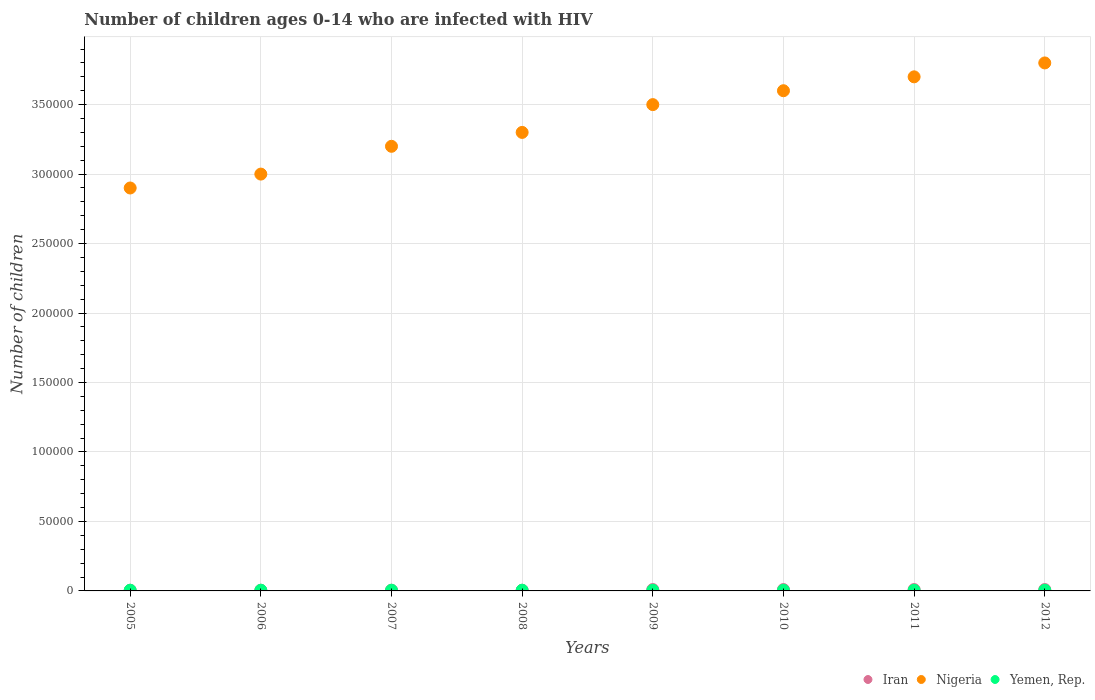Is the number of dotlines equal to the number of legend labels?
Make the answer very short. Yes. What is the number of HIV infected children in Yemen, Rep. in 2008?
Offer a terse response. 500. Across all years, what is the maximum number of HIV infected children in Yemen, Rep.?
Your answer should be compact. 500. Across all years, what is the minimum number of HIV infected children in Iran?
Provide a succinct answer. 500. In which year was the number of HIV infected children in Iran maximum?
Offer a terse response. 2009. What is the total number of HIV infected children in Yemen, Rep. in the graph?
Make the answer very short. 4000. What is the difference between the number of HIV infected children in Iran in 2005 and that in 2008?
Ensure brevity in your answer.  0. What is the difference between the number of HIV infected children in Iran in 2012 and the number of HIV infected children in Nigeria in 2008?
Provide a short and direct response. -3.29e+05. What is the average number of HIV infected children in Yemen, Rep. per year?
Ensure brevity in your answer.  500. In the year 2006, what is the difference between the number of HIV infected children in Yemen, Rep. and number of HIV infected children in Nigeria?
Offer a terse response. -3.00e+05. What is the ratio of the number of HIV infected children in Nigeria in 2005 to that in 2007?
Offer a terse response. 0.91. Is the number of HIV infected children in Yemen, Rep. in 2005 less than that in 2010?
Offer a terse response. No. What is the difference between the highest and the second highest number of HIV infected children in Iran?
Give a very brief answer. 0. What is the difference between the highest and the lowest number of HIV infected children in Yemen, Rep.?
Provide a short and direct response. 0. In how many years, is the number of HIV infected children in Nigeria greater than the average number of HIV infected children in Nigeria taken over all years?
Make the answer very short. 4. How many dotlines are there?
Ensure brevity in your answer.  3. Does the graph contain any zero values?
Ensure brevity in your answer.  No. Where does the legend appear in the graph?
Ensure brevity in your answer.  Bottom right. How many legend labels are there?
Make the answer very short. 3. What is the title of the graph?
Make the answer very short. Number of children ages 0-14 who are infected with HIV. What is the label or title of the X-axis?
Your response must be concise. Years. What is the label or title of the Y-axis?
Provide a succinct answer. Number of children. What is the Number of children of Iran in 2005?
Ensure brevity in your answer.  500. What is the Number of children of Nigeria in 2005?
Make the answer very short. 2.90e+05. What is the Number of children in Yemen, Rep. in 2005?
Offer a terse response. 500. What is the Number of children of Nigeria in 2006?
Your response must be concise. 3.00e+05. What is the Number of children of Nigeria in 2007?
Ensure brevity in your answer.  3.20e+05. What is the Number of children in Nigeria in 2008?
Ensure brevity in your answer.  3.30e+05. What is the Number of children in Yemen, Rep. in 2008?
Your answer should be very brief. 500. What is the Number of children of Nigeria in 2009?
Offer a very short reply. 3.50e+05. What is the Number of children in Yemen, Rep. in 2009?
Provide a succinct answer. 500. What is the Number of children of Yemen, Rep. in 2010?
Offer a very short reply. 500. What is the Number of children in Iran in 2011?
Provide a short and direct response. 1000. What is the Number of children in Yemen, Rep. in 2011?
Offer a very short reply. 500. What is the Number of children in Iran in 2012?
Offer a terse response. 1000. What is the Number of children in Yemen, Rep. in 2012?
Provide a succinct answer. 500. Across all years, what is the maximum Number of children of Iran?
Provide a succinct answer. 1000. Across all years, what is the maximum Number of children of Yemen, Rep.?
Your response must be concise. 500. What is the total Number of children in Iran in the graph?
Give a very brief answer. 6000. What is the total Number of children of Nigeria in the graph?
Ensure brevity in your answer.  2.70e+06. What is the total Number of children in Yemen, Rep. in the graph?
Your answer should be very brief. 4000. What is the difference between the Number of children in Yemen, Rep. in 2005 and that in 2006?
Offer a very short reply. 0. What is the difference between the Number of children in Iran in 2005 and that in 2007?
Provide a succinct answer. 0. What is the difference between the Number of children of Nigeria in 2005 and that in 2008?
Your answer should be compact. -4.00e+04. What is the difference between the Number of children of Yemen, Rep. in 2005 and that in 2008?
Your answer should be very brief. 0. What is the difference between the Number of children in Iran in 2005 and that in 2009?
Keep it short and to the point. -500. What is the difference between the Number of children in Nigeria in 2005 and that in 2009?
Give a very brief answer. -6.00e+04. What is the difference between the Number of children of Iran in 2005 and that in 2010?
Offer a very short reply. -500. What is the difference between the Number of children of Nigeria in 2005 and that in 2010?
Ensure brevity in your answer.  -7.00e+04. What is the difference between the Number of children of Yemen, Rep. in 2005 and that in 2010?
Make the answer very short. 0. What is the difference between the Number of children of Iran in 2005 and that in 2011?
Your answer should be very brief. -500. What is the difference between the Number of children of Iran in 2005 and that in 2012?
Give a very brief answer. -500. What is the difference between the Number of children in Yemen, Rep. in 2006 and that in 2007?
Ensure brevity in your answer.  0. What is the difference between the Number of children of Iran in 2006 and that in 2008?
Your response must be concise. 0. What is the difference between the Number of children in Yemen, Rep. in 2006 and that in 2008?
Your answer should be compact. 0. What is the difference between the Number of children of Iran in 2006 and that in 2009?
Offer a very short reply. -500. What is the difference between the Number of children in Nigeria in 2006 and that in 2009?
Give a very brief answer. -5.00e+04. What is the difference between the Number of children of Iran in 2006 and that in 2010?
Provide a short and direct response. -500. What is the difference between the Number of children of Iran in 2006 and that in 2011?
Keep it short and to the point. -500. What is the difference between the Number of children of Nigeria in 2006 and that in 2011?
Ensure brevity in your answer.  -7.00e+04. What is the difference between the Number of children in Iran in 2006 and that in 2012?
Make the answer very short. -500. What is the difference between the Number of children of Nigeria in 2007 and that in 2008?
Ensure brevity in your answer.  -10000. What is the difference between the Number of children of Yemen, Rep. in 2007 and that in 2008?
Provide a succinct answer. 0. What is the difference between the Number of children in Iran in 2007 and that in 2009?
Provide a succinct answer. -500. What is the difference between the Number of children of Nigeria in 2007 and that in 2009?
Provide a short and direct response. -3.00e+04. What is the difference between the Number of children in Yemen, Rep. in 2007 and that in 2009?
Provide a succinct answer. 0. What is the difference between the Number of children in Iran in 2007 and that in 2010?
Your answer should be very brief. -500. What is the difference between the Number of children in Yemen, Rep. in 2007 and that in 2010?
Ensure brevity in your answer.  0. What is the difference between the Number of children of Iran in 2007 and that in 2011?
Provide a succinct answer. -500. What is the difference between the Number of children of Nigeria in 2007 and that in 2011?
Offer a very short reply. -5.00e+04. What is the difference between the Number of children of Iran in 2007 and that in 2012?
Your answer should be very brief. -500. What is the difference between the Number of children of Yemen, Rep. in 2007 and that in 2012?
Offer a very short reply. 0. What is the difference between the Number of children in Iran in 2008 and that in 2009?
Ensure brevity in your answer.  -500. What is the difference between the Number of children in Iran in 2008 and that in 2010?
Provide a succinct answer. -500. What is the difference between the Number of children of Iran in 2008 and that in 2011?
Your response must be concise. -500. What is the difference between the Number of children of Iran in 2008 and that in 2012?
Offer a terse response. -500. What is the difference between the Number of children in Nigeria in 2008 and that in 2012?
Your answer should be compact. -5.00e+04. What is the difference between the Number of children in Yemen, Rep. in 2008 and that in 2012?
Your answer should be compact. 0. What is the difference between the Number of children in Nigeria in 2009 and that in 2010?
Keep it short and to the point. -10000. What is the difference between the Number of children of Nigeria in 2009 and that in 2012?
Ensure brevity in your answer.  -3.00e+04. What is the difference between the Number of children in Yemen, Rep. in 2009 and that in 2012?
Provide a short and direct response. 0. What is the difference between the Number of children in Nigeria in 2010 and that in 2011?
Your answer should be compact. -10000. What is the difference between the Number of children in Yemen, Rep. in 2010 and that in 2011?
Provide a short and direct response. 0. What is the difference between the Number of children of Iran in 2010 and that in 2012?
Provide a short and direct response. 0. What is the difference between the Number of children of Nigeria in 2010 and that in 2012?
Give a very brief answer. -2.00e+04. What is the difference between the Number of children of Yemen, Rep. in 2010 and that in 2012?
Offer a very short reply. 0. What is the difference between the Number of children of Iran in 2011 and that in 2012?
Your response must be concise. 0. What is the difference between the Number of children in Yemen, Rep. in 2011 and that in 2012?
Offer a terse response. 0. What is the difference between the Number of children in Iran in 2005 and the Number of children in Nigeria in 2006?
Provide a short and direct response. -3.00e+05. What is the difference between the Number of children in Nigeria in 2005 and the Number of children in Yemen, Rep. in 2006?
Provide a short and direct response. 2.90e+05. What is the difference between the Number of children of Iran in 2005 and the Number of children of Nigeria in 2007?
Make the answer very short. -3.20e+05. What is the difference between the Number of children in Iran in 2005 and the Number of children in Yemen, Rep. in 2007?
Provide a short and direct response. 0. What is the difference between the Number of children of Nigeria in 2005 and the Number of children of Yemen, Rep. in 2007?
Ensure brevity in your answer.  2.90e+05. What is the difference between the Number of children of Iran in 2005 and the Number of children of Nigeria in 2008?
Offer a very short reply. -3.30e+05. What is the difference between the Number of children in Iran in 2005 and the Number of children in Yemen, Rep. in 2008?
Offer a very short reply. 0. What is the difference between the Number of children of Nigeria in 2005 and the Number of children of Yemen, Rep. in 2008?
Provide a short and direct response. 2.90e+05. What is the difference between the Number of children in Iran in 2005 and the Number of children in Nigeria in 2009?
Your answer should be very brief. -3.50e+05. What is the difference between the Number of children of Nigeria in 2005 and the Number of children of Yemen, Rep. in 2009?
Provide a short and direct response. 2.90e+05. What is the difference between the Number of children in Iran in 2005 and the Number of children in Nigeria in 2010?
Your response must be concise. -3.60e+05. What is the difference between the Number of children in Iran in 2005 and the Number of children in Yemen, Rep. in 2010?
Provide a succinct answer. 0. What is the difference between the Number of children of Nigeria in 2005 and the Number of children of Yemen, Rep. in 2010?
Keep it short and to the point. 2.90e+05. What is the difference between the Number of children of Iran in 2005 and the Number of children of Nigeria in 2011?
Provide a short and direct response. -3.70e+05. What is the difference between the Number of children in Iran in 2005 and the Number of children in Yemen, Rep. in 2011?
Your answer should be very brief. 0. What is the difference between the Number of children of Nigeria in 2005 and the Number of children of Yemen, Rep. in 2011?
Offer a terse response. 2.90e+05. What is the difference between the Number of children of Iran in 2005 and the Number of children of Nigeria in 2012?
Offer a terse response. -3.80e+05. What is the difference between the Number of children of Nigeria in 2005 and the Number of children of Yemen, Rep. in 2012?
Provide a short and direct response. 2.90e+05. What is the difference between the Number of children of Iran in 2006 and the Number of children of Nigeria in 2007?
Your answer should be compact. -3.20e+05. What is the difference between the Number of children in Nigeria in 2006 and the Number of children in Yemen, Rep. in 2007?
Your answer should be compact. 3.00e+05. What is the difference between the Number of children in Iran in 2006 and the Number of children in Nigeria in 2008?
Your answer should be compact. -3.30e+05. What is the difference between the Number of children in Iran in 2006 and the Number of children in Yemen, Rep. in 2008?
Provide a short and direct response. 0. What is the difference between the Number of children of Nigeria in 2006 and the Number of children of Yemen, Rep. in 2008?
Your answer should be very brief. 3.00e+05. What is the difference between the Number of children of Iran in 2006 and the Number of children of Nigeria in 2009?
Your answer should be very brief. -3.50e+05. What is the difference between the Number of children in Iran in 2006 and the Number of children in Yemen, Rep. in 2009?
Offer a terse response. 0. What is the difference between the Number of children of Nigeria in 2006 and the Number of children of Yemen, Rep. in 2009?
Provide a short and direct response. 3.00e+05. What is the difference between the Number of children in Iran in 2006 and the Number of children in Nigeria in 2010?
Give a very brief answer. -3.60e+05. What is the difference between the Number of children of Nigeria in 2006 and the Number of children of Yemen, Rep. in 2010?
Provide a succinct answer. 3.00e+05. What is the difference between the Number of children in Iran in 2006 and the Number of children in Nigeria in 2011?
Offer a terse response. -3.70e+05. What is the difference between the Number of children of Iran in 2006 and the Number of children of Yemen, Rep. in 2011?
Offer a terse response. 0. What is the difference between the Number of children in Nigeria in 2006 and the Number of children in Yemen, Rep. in 2011?
Give a very brief answer. 3.00e+05. What is the difference between the Number of children of Iran in 2006 and the Number of children of Nigeria in 2012?
Your response must be concise. -3.80e+05. What is the difference between the Number of children in Nigeria in 2006 and the Number of children in Yemen, Rep. in 2012?
Provide a succinct answer. 3.00e+05. What is the difference between the Number of children in Iran in 2007 and the Number of children in Nigeria in 2008?
Provide a short and direct response. -3.30e+05. What is the difference between the Number of children in Nigeria in 2007 and the Number of children in Yemen, Rep. in 2008?
Offer a very short reply. 3.20e+05. What is the difference between the Number of children in Iran in 2007 and the Number of children in Nigeria in 2009?
Your answer should be compact. -3.50e+05. What is the difference between the Number of children of Nigeria in 2007 and the Number of children of Yemen, Rep. in 2009?
Your answer should be very brief. 3.20e+05. What is the difference between the Number of children of Iran in 2007 and the Number of children of Nigeria in 2010?
Your response must be concise. -3.60e+05. What is the difference between the Number of children in Iran in 2007 and the Number of children in Yemen, Rep. in 2010?
Provide a short and direct response. 0. What is the difference between the Number of children of Nigeria in 2007 and the Number of children of Yemen, Rep. in 2010?
Provide a succinct answer. 3.20e+05. What is the difference between the Number of children of Iran in 2007 and the Number of children of Nigeria in 2011?
Offer a very short reply. -3.70e+05. What is the difference between the Number of children of Nigeria in 2007 and the Number of children of Yemen, Rep. in 2011?
Offer a very short reply. 3.20e+05. What is the difference between the Number of children of Iran in 2007 and the Number of children of Nigeria in 2012?
Give a very brief answer. -3.80e+05. What is the difference between the Number of children in Nigeria in 2007 and the Number of children in Yemen, Rep. in 2012?
Give a very brief answer. 3.20e+05. What is the difference between the Number of children in Iran in 2008 and the Number of children in Nigeria in 2009?
Offer a terse response. -3.50e+05. What is the difference between the Number of children in Iran in 2008 and the Number of children in Yemen, Rep. in 2009?
Give a very brief answer. 0. What is the difference between the Number of children of Nigeria in 2008 and the Number of children of Yemen, Rep. in 2009?
Ensure brevity in your answer.  3.30e+05. What is the difference between the Number of children of Iran in 2008 and the Number of children of Nigeria in 2010?
Provide a succinct answer. -3.60e+05. What is the difference between the Number of children of Nigeria in 2008 and the Number of children of Yemen, Rep. in 2010?
Ensure brevity in your answer.  3.30e+05. What is the difference between the Number of children of Iran in 2008 and the Number of children of Nigeria in 2011?
Offer a terse response. -3.70e+05. What is the difference between the Number of children in Nigeria in 2008 and the Number of children in Yemen, Rep. in 2011?
Your response must be concise. 3.30e+05. What is the difference between the Number of children of Iran in 2008 and the Number of children of Nigeria in 2012?
Provide a succinct answer. -3.80e+05. What is the difference between the Number of children of Nigeria in 2008 and the Number of children of Yemen, Rep. in 2012?
Provide a succinct answer. 3.30e+05. What is the difference between the Number of children in Iran in 2009 and the Number of children in Nigeria in 2010?
Offer a terse response. -3.59e+05. What is the difference between the Number of children of Iran in 2009 and the Number of children of Yemen, Rep. in 2010?
Make the answer very short. 500. What is the difference between the Number of children in Nigeria in 2009 and the Number of children in Yemen, Rep. in 2010?
Your response must be concise. 3.50e+05. What is the difference between the Number of children in Iran in 2009 and the Number of children in Nigeria in 2011?
Your answer should be compact. -3.69e+05. What is the difference between the Number of children of Iran in 2009 and the Number of children of Yemen, Rep. in 2011?
Provide a short and direct response. 500. What is the difference between the Number of children in Nigeria in 2009 and the Number of children in Yemen, Rep. in 2011?
Give a very brief answer. 3.50e+05. What is the difference between the Number of children of Iran in 2009 and the Number of children of Nigeria in 2012?
Keep it short and to the point. -3.79e+05. What is the difference between the Number of children in Nigeria in 2009 and the Number of children in Yemen, Rep. in 2012?
Provide a succinct answer. 3.50e+05. What is the difference between the Number of children of Iran in 2010 and the Number of children of Nigeria in 2011?
Keep it short and to the point. -3.69e+05. What is the difference between the Number of children in Nigeria in 2010 and the Number of children in Yemen, Rep. in 2011?
Provide a short and direct response. 3.60e+05. What is the difference between the Number of children of Iran in 2010 and the Number of children of Nigeria in 2012?
Your response must be concise. -3.79e+05. What is the difference between the Number of children of Nigeria in 2010 and the Number of children of Yemen, Rep. in 2012?
Keep it short and to the point. 3.60e+05. What is the difference between the Number of children in Iran in 2011 and the Number of children in Nigeria in 2012?
Your answer should be very brief. -3.79e+05. What is the difference between the Number of children of Iran in 2011 and the Number of children of Yemen, Rep. in 2012?
Offer a very short reply. 500. What is the difference between the Number of children in Nigeria in 2011 and the Number of children in Yemen, Rep. in 2012?
Keep it short and to the point. 3.70e+05. What is the average Number of children in Iran per year?
Provide a short and direct response. 750. What is the average Number of children of Nigeria per year?
Offer a terse response. 3.38e+05. In the year 2005, what is the difference between the Number of children in Iran and Number of children in Nigeria?
Give a very brief answer. -2.90e+05. In the year 2005, what is the difference between the Number of children of Iran and Number of children of Yemen, Rep.?
Your answer should be very brief. 0. In the year 2005, what is the difference between the Number of children of Nigeria and Number of children of Yemen, Rep.?
Provide a succinct answer. 2.90e+05. In the year 2006, what is the difference between the Number of children of Iran and Number of children of Nigeria?
Make the answer very short. -3.00e+05. In the year 2006, what is the difference between the Number of children in Iran and Number of children in Yemen, Rep.?
Offer a terse response. 0. In the year 2006, what is the difference between the Number of children of Nigeria and Number of children of Yemen, Rep.?
Make the answer very short. 3.00e+05. In the year 2007, what is the difference between the Number of children in Iran and Number of children in Nigeria?
Give a very brief answer. -3.20e+05. In the year 2007, what is the difference between the Number of children in Nigeria and Number of children in Yemen, Rep.?
Your response must be concise. 3.20e+05. In the year 2008, what is the difference between the Number of children of Iran and Number of children of Nigeria?
Give a very brief answer. -3.30e+05. In the year 2008, what is the difference between the Number of children in Iran and Number of children in Yemen, Rep.?
Make the answer very short. 0. In the year 2008, what is the difference between the Number of children of Nigeria and Number of children of Yemen, Rep.?
Keep it short and to the point. 3.30e+05. In the year 2009, what is the difference between the Number of children in Iran and Number of children in Nigeria?
Your answer should be very brief. -3.49e+05. In the year 2009, what is the difference between the Number of children in Iran and Number of children in Yemen, Rep.?
Give a very brief answer. 500. In the year 2009, what is the difference between the Number of children of Nigeria and Number of children of Yemen, Rep.?
Make the answer very short. 3.50e+05. In the year 2010, what is the difference between the Number of children of Iran and Number of children of Nigeria?
Provide a short and direct response. -3.59e+05. In the year 2010, what is the difference between the Number of children in Nigeria and Number of children in Yemen, Rep.?
Offer a terse response. 3.60e+05. In the year 2011, what is the difference between the Number of children of Iran and Number of children of Nigeria?
Your answer should be very brief. -3.69e+05. In the year 2011, what is the difference between the Number of children of Iran and Number of children of Yemen, Rep.?
Keep it short and to the point. 500. In the year 2011, what is the difference between the Number of children in Nigeria and Number of children in Yemen, Rep.?
Your answer should be compact. 3.70e+05. In the year 2012, what is the difference between the Number of children in Iran and Number of children in Nigeria?
Ensure brevity in your answer.  -3.79e+05. In the year 2012, what is the difference between the Number of children in Iran and Number of children in Yemen, Rep.?
Provide a short and direct response. 500. In the year 2012, what is the difference between the Number of children in Nigeria and Number of children in Yemen, Rep.?
Give a very brief answer. 3.80e+05. What is the ratio of the Number of children of Iran in 2005 to that in 2006?
Give a very brief answer. 1. What is the ratio of the Number of children of Nigeria in 2005 to that in 2006?
Offer a terse response. 0.97. What is the ratio of the Number of children of Yemen, Rep. in 2005 to that in 2006?
Make the answer very short. 1. What is the ratio of the Number of children in Iran in 2005 to that in 2007?
Offer a very short reply. 1. What is the ratio of the Number of children in Nigeria in 2005 to that in 2007?
Keep it short and to the point. 0.91. What is the ratio of the Number of children in Yemen, Rep. in 2005 to that in 2007?
Offer a terse response. 1. What is the ratio of the Number of children in Nigeria in 2005 to that in 2008?
Your response must be concise. 0.88. What is the ratio of the Number of children in Nigeria in 2005 to that in 2009?
Ensure brevity in your answer.  0.83. What is the ratio of the Number of children in Yemen, Rep. in 2005 to that in 2009?
Your answer should be compact. 1. What is the ratio of the Number of children in Iran in 2005 to that in 2010?
Your answer should be very brief. 0.5. What is the ratio of the Number of children of Nigeria in 2005 to that in 2010?
Provide a short and direct response. 0.81. What is the ratio of the Number of children in Nigeria in 2005 to that in 2011?
Offer a very short reply. 0.78. What is the ratio of the Number of children of Nigeria in 2005 to that in 2012?
Offer a terse response. 0.76. What is the ratio of the Number of children in Yemen, Rep. in 2005 to that in 2012?
Offer a very short reply. 1. What is the ratio of the Number of children of Nigeria in 2006 to that in 2007?
Your response must be concise. 0.94. What is the ratio of the Number of children of Yemen, Rep. in 2006 to that in 2007?
Give a very brief answer. 1. What is the ratio of the Number of children in Nigeria in 2006 to that in 2008?
Keep it short and to the point. 0.91. What is the ratio of the Number of children of Iran in 2006 to that in 2009?
Provide a short and direct response. 0.5. What is the ratio of the Number of children in Yemen, Rep. in 2006 to that in 2009?
Give a very brief answer. 1. What is the ratio of the Number of children of Iran in 2006 to that in 2010?
Your response must be concise. 0.5. What is the ratio of the Number of children of Yemen, Rep. in 2006 to that in 2010?
Offer a very short reply. 1. What is the ratio of the Number of children in Nigeria in 2006 to that in 2011?
Your answer should be very brief. 0.81. What is the ratio of the Number of children in Yemen, Rep. in 2006 to that in 2011?
Your answer should be compact. 1. What is the ratio of the Number of children of Nigeria in 2006 to that in 2012?
Your answer should be compact. 0.79. What is the ratio of the Number of children of Yemen, Rep. in 2006 to that in 2012?
Keep it short and to the point. 1. What is the ratio of the Number of children in Iran in 2007 to that in 2008?
Offer a terse response. 1. What is the ratio of the Number of children of Nigeria in 2007 to that in 2008?
Your answer should be very brief. 0.97. What is the ratio of the Number of children of Iran in 2007 to that in 2009?
Make the answer very short. 0.5. What is the ratio of the Number of children of Nigeria in 2007 to that in 2009?
Make the answer very short. 0.91. What is the ratio of the Number of children of Yemen, Rep. in 2007 to that in 2009?
Give a very brief answer. 1. What is the ratio of the Number of children of Nigeria in 2007 to that in 2010?
Give a very brief answer. 0.89. What is the ratio of the Number of children in Yemen, Rep. in 2007 to that in 2010?
Keep it short and to the point. 1. What is the ratio of the Number of children in Nigeria in 2007 to that in 2011?
Give a very brief answer. 0.86. What is the ratio of the Number of children of Iran in 2007 to that in 2012?
Offer a very short reply. 0.5. What is the ratio of the Number of children of Nigeria in 2007 to that in 2012?
Ensure brevity in your answer.  0.84. What is the ratio of the Number of children in Nigeria in 2008 to that in 2009?
Provide a succinct answer. 0.94. What is the ratio of the Number of children in Yemen, Rep. in 2008 to that in 2009?
Provide a short and direct response. 1. What is the ratio of the Number of children in Nigeria in 2008 to that in 2011?
Offer a terse response. 0.89. What is the ratio of the Number of children of Nigeria in 2008 to that in 2012?
Give a very brief answer. 0.87. What is the ratio of the Number of children in Nigeria in 2009 to that in 2010?
Ensure brevity in your answer.  0.97. What is the ratio of the Number of children in Yemen, Rep. in 2009 to that in 2010?
Give a very brief answer. 1. What is the ratio of the Number of children of Nigeria in 2009 to that in 2011?
Offer a very short reply. 0.95. What is the ratio of the Number of children in Iran in 2009 to that in 2012?
Your answer should be compact. 1. What is the ratio of the Number of children in Nigeria in 2009 to that in 2012?
Provide a succinct answer. 0.92. What is the ratio of the Number of children of Iran in 2010 to that in 2011?
Provide a short and direct response. 1. What is the ratio of the Number of children of Iran in 2011 to that in 2012?
Your answer should be compact. 1. What is the ratio of the Number of children of Nigeria in 2011 to that in 2012?
Your answer should be compact. 0.97. What is the ratio of the Number of children of Yemen, Rep. in 2011 to that in 2012?
Make the answer very short. 1. What is the difference between the highest and the second highest Number of children of Nigeria?
Ensure brevity in your answer.  10000. What is the difference between the highest and the lowest Number of children of Iran?
Your answer should be very brief. 500. What is the difference between the highest and the lowest Number of children of Nigeria?
Your answer should be compact. 9.00e+04. 